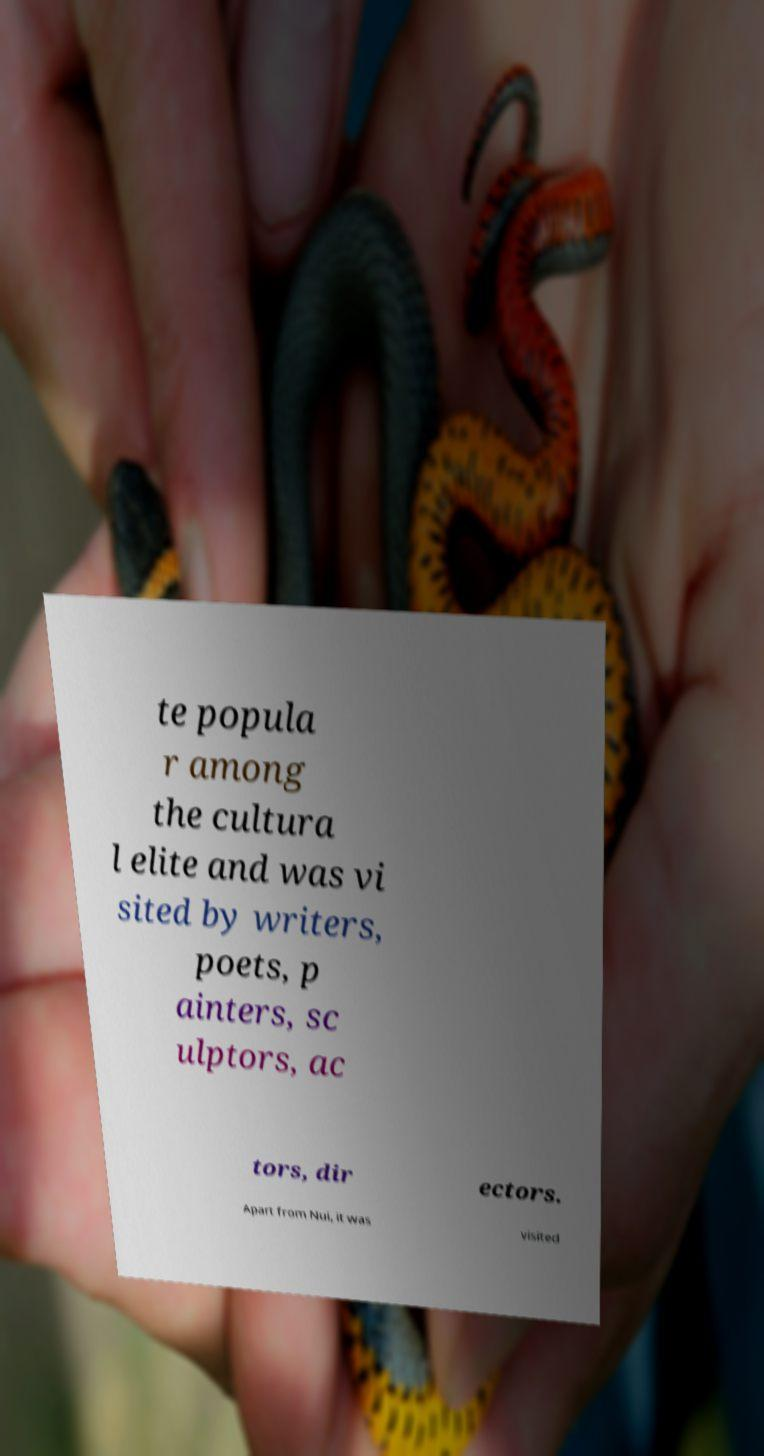For documentation purposes, I need the text within this image transcribed. Could you provide that? te popula r among the cultura l elite and was vi sited by writers, poets, p ainters, sc ulptors, ac tors, dir ectors. Apart from Nui, it was visited 